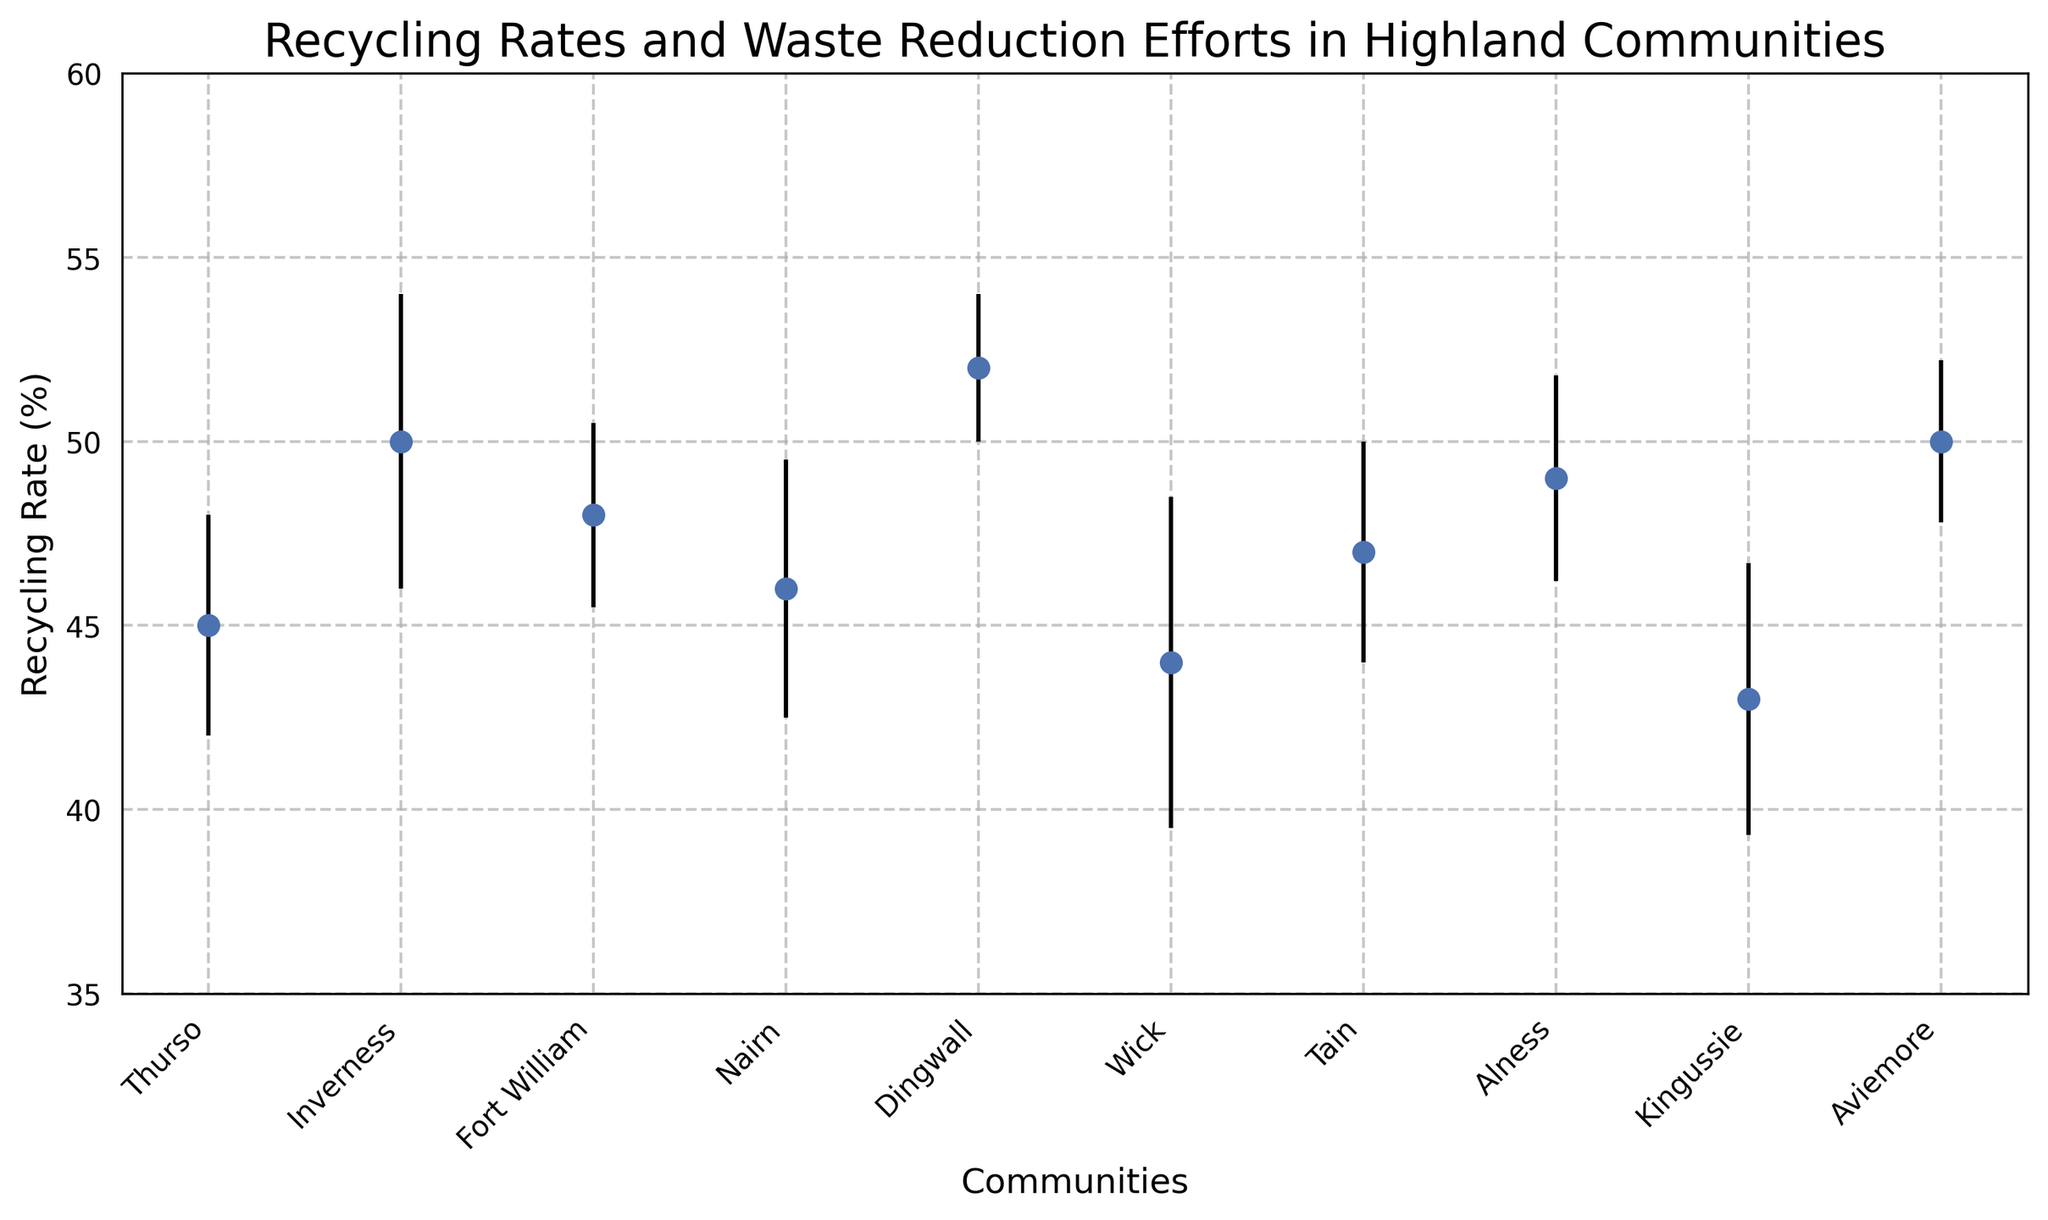Which community has the highest recycling rate? The community with the tallest marker on the chart represents the highest recycling rate. The label for this community is read directly from the x-axis.
Answer: Dingwall Which community has the lowest recycling rate? The community with the shortest marker on the chart represents the lowest recycling rate. The label for this community is read directly from the x-axis.
Answer: Kingussie What is the average recycling rate of communities with 'High' waste reduction efforts? Identify the recycling rates of Thurso, Fort William, Dingwall, Alness, and Aviemore. Compute the average: (45 + 48 + 52 + 49 + 50) / 5 = 244 / 5 = 48.8
Answer: 48.8 How does the recycling rate of Thurso compare to Alness? Look at the heights of the markers for Thurso and Alness. Thurso has a recycling rate of 45%, while Alness has a recycling rate of 49%. This means Alness has a higher recycling rate than Thurso.
Answer: Alness is higher Which community has the smallest error margin? The community with the shortest vertical error bar representing the smallest margin is identified by comparing the lengths of all error bars.
Answer: Dingwall Which community has a medium level of waste reduction efforts and a recycling rate closest to the overall median? Identify communities with 'Medium' waste reduction efforts: Inverness (50), Nairn (46), Tain (47), Kingussie (43). Order these rates: 43, 46, 47, 50. The median value is 46.
Answer: Nairn What is the range of recycling rates among the communities? Identify the minimum and maximum recycling rates from the chart (43% for Kingussie and 52% for Dingwall, respectively) and compute the range: 52 - 43 = 9.
Answer: 9 Which community with 'Low' waste reduction efforts has a recycling rate of 44%? Locate the communities with 'Low' waste reduction efforts and check their recycling rates. The chart shows Wick has a 44% recycling rate.
Answer: Wick 